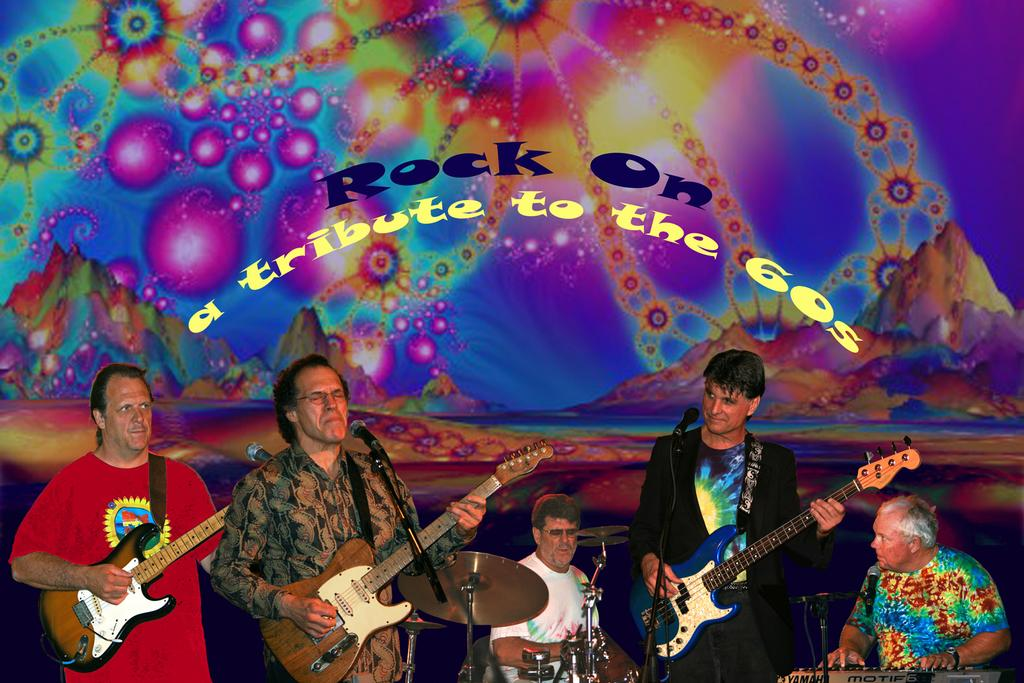How many people are in the image? There are people in the image, but the exact number is not specified. What are the people doing in the image? The people are standing and playing musical instruments. What type of image is it? The image is animated. What color is the ink used to draw the shape in the image? There is no shape or ink present in the image; it features people playing musical instruments in an animated setting. 